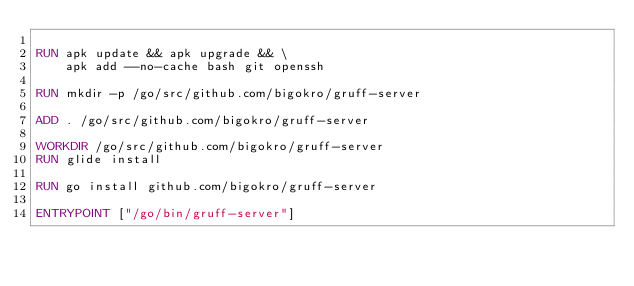Convert code to text. <code><loc_0><loc_0><loc_500><loc_500><_Dockerfile_>
RUN apk update && apk upgrade && \
    apk add --no-cache bash git openssh

RUN mkdir -p /go/src/github.com/bigokro/gruff-server

ADD . /go/src/github.com/bigokro/gruff-server

WORKDIR /go/src/github.com/bigokro/gruff-server
RUN glide install
    
RUN go install github.com/bigokro/gruff-server

ENTRYPOINT ["/go/bin/gruff-server"]</code> 